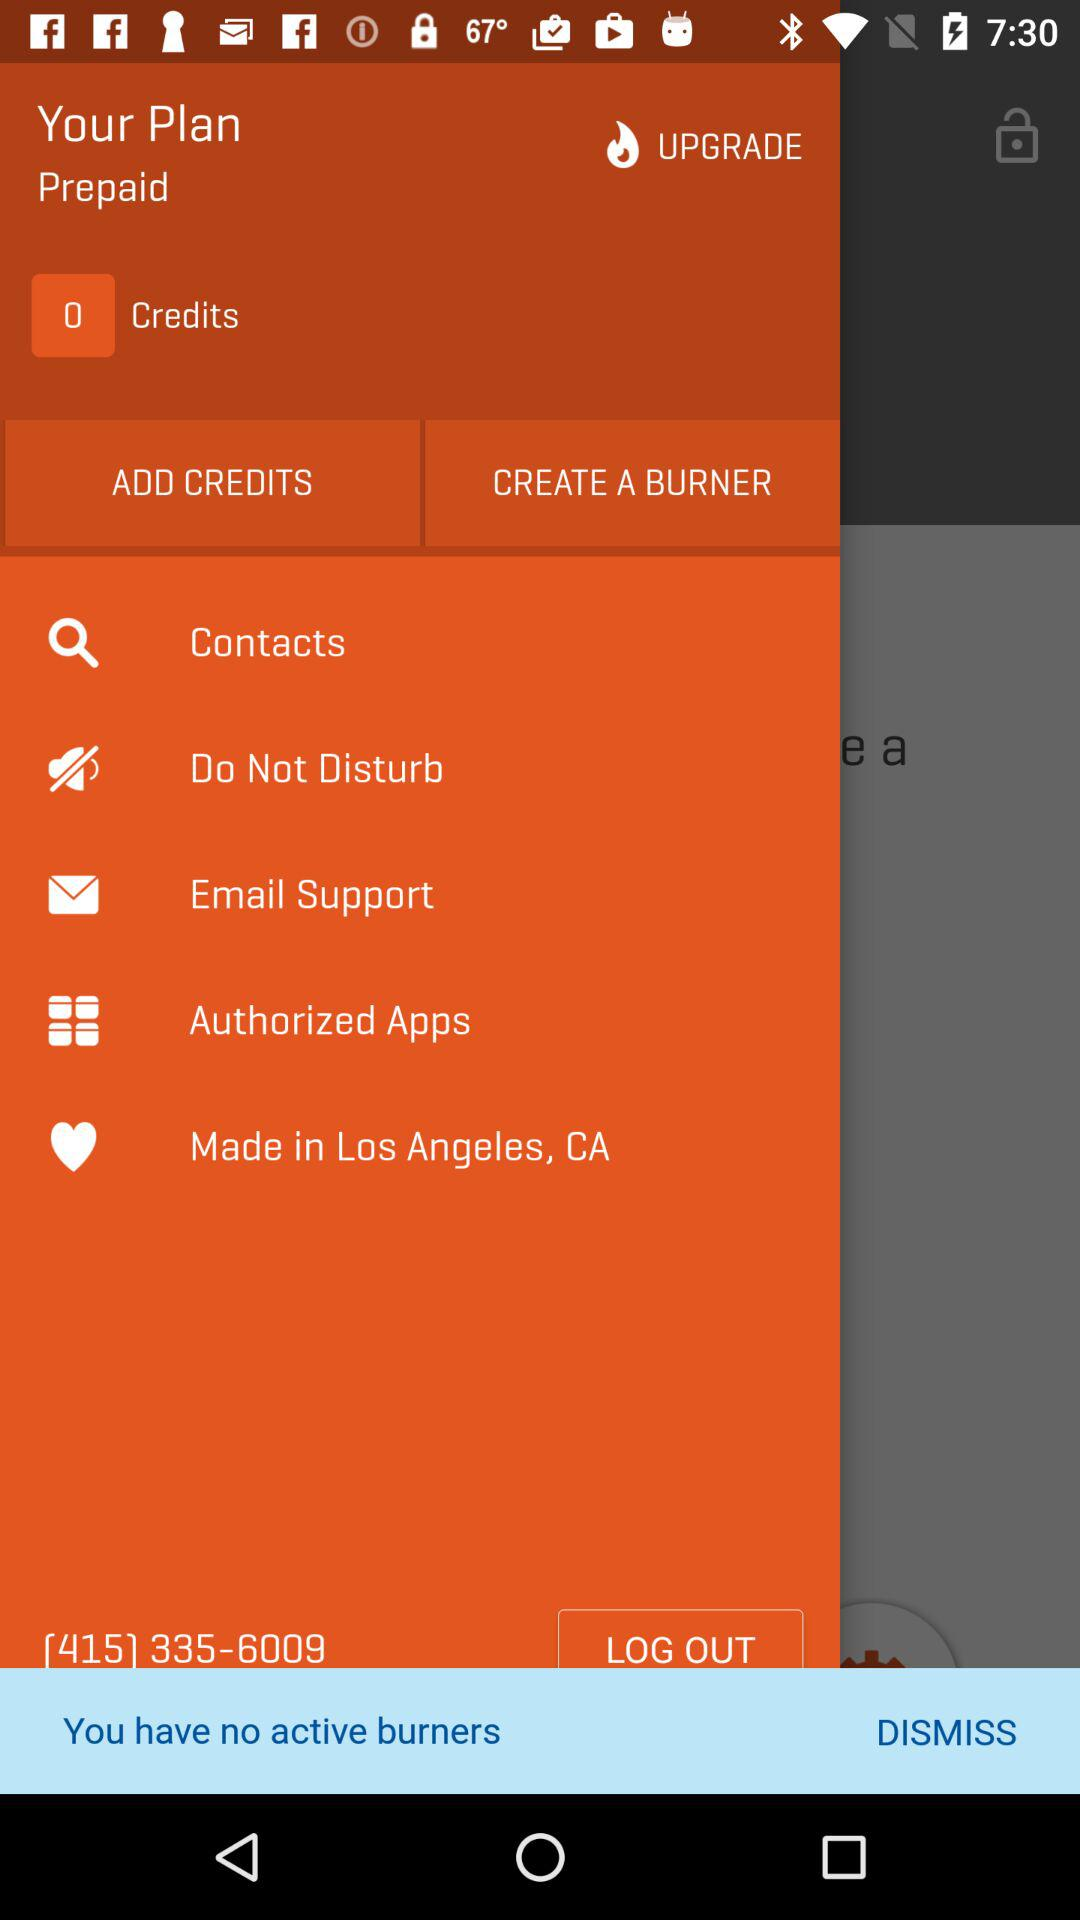What is the login phone number? The login phone number is [415] 335-6009. 